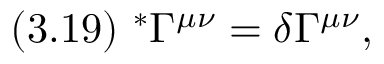<formula> <loc_0><loc_0><loc_500><loc_500>( 3 . 1 9 ) \ ^ { * } \Gamma ^ { \mu \nu } = \delta \Gamma ^ { \mu \nu } ,</formula> 